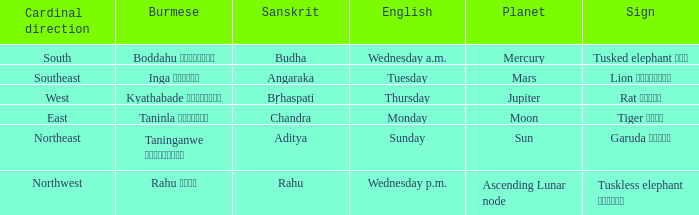State the name of day in english where cardinal direction is east Monday. I'm looking to parse the entire table for insights. Could you assist me with that? {'header': ['Cardinal direction', 'Burmese', 'Sanskrit', 'English', 'Planet', 'Sign'], 'rows': [['South', 'Boddahu ဗုဒ္ဓဟူး', 'Budha', 'Wednesday a.m.', 'Mercury', 'Tusked elephant ဆင်'], ['Southeast', 'Inga အင်္ဂါ', 'Angaraka', 'Tuesday', 'Mars', 'Lion ခြင်္သေ့'], ['West', 'Kyathabade ကြာသပတေး', 'Bṛhaspati', 'Thursday', 'Jupiter', 'Rat ကြွက်'], ['East', 'Taninla တနင်္လာ', 'Chandra', 'Monday', 'Moon', 'Tiger ကျား'], ['Northeast', 'Taninganwe တနင်္ဂနွေ', 'Aditya', 'Sunday', 'Sun', 'Garuda ဂဠုန်'], ['Northwest', 'Rahu ရာဟု', 'Rahu', 'Wednesday p.m.', 'Ascending Lunar node', 'Tuskless elephant ဟိုင်း']]} 